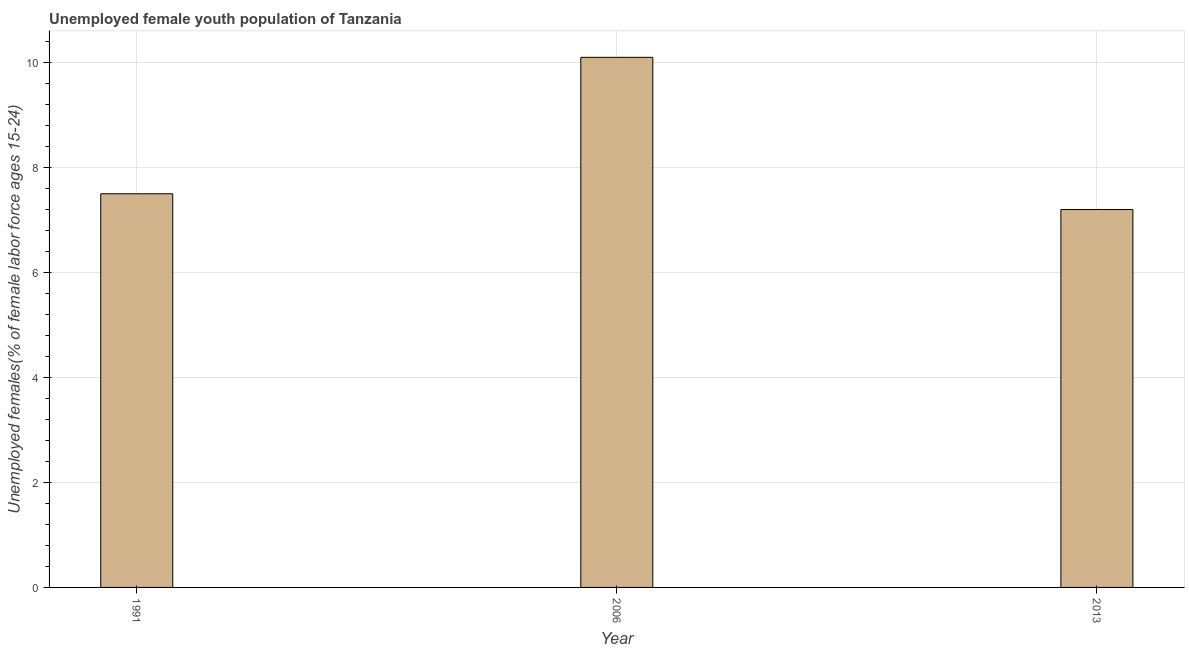Does the graph contain any zero values?
Ensure brevity in your answer.  No. Does the graph contain grids?
Offer a terse response. Yes. What is the title of the graph?
Give a very brief answer. Unemployed female youth population of Tanzania. What is the label or title of the Y-axis?
Your answer should be compact. Unemployed females(% of female labor force ages 15-24). What is the unemployed female youth in 2013?
Your answer should be compact. 7.2. Across all years, what is the maximum unemployed female youth?
Your response must be concise. 10.1. Across all years, what is the minimum unemployed female youth?
Ensure brevity in your answer.  7.2. What is the sum of the unemployed female youth?
Offer a terse response. 24.8. What is the average unemployed female youth per year?
Offer a terse response. 8.27. What is the median unemployed female youth?
Make the answer very short. 7.5. What is the ratio of the unemployed female youth in 1991 to that in 2013?
Your answer should be very brief. 1.04. Is the unemployed female youth in 2006 less than that in 2013?
Make the answer very short. No. Is the difference between the unemployed female youth in 1991 and 2013 greater than the difference between any two years?
Offer a terse response. No. Is the sum of the unemployed female youth in 2006 and 2013 greater than the maximum unemployed female youth across all years?
Offer a terse response. Yes. In how many years, is the unemployed female youth greater than the average unemployed female youth taken over all years?
Your answer should be compact. 1. Are all the bars in the graph horizontal?
Ensure brevity in your answer.  No. What is the difference between two consecutive major ticks on the Y-axis?
Give a very brief answer. 2. What is the Unemployed females(% of female labor force ages 15-24) of 2006?
Make the answer very short. 10.1. What is the Unemployed females(% of female labor force ages 15-24) in 2013?
Offer a very short reply. 7.2. What is the difference between the Unemployed females(% of female labor force ages 15-24) in 1991 and 2006?
Your response must be concise. -2.6. What is the ratio of the Unemployed females(% of female labor force ages 15-24) in 1991 to that in 2006?
Give a very brief answer. 0.74. What is the ratio of the Unemployed females(% of female labor force ages 15-24) in 1991 to that in 2013?
Your response must be concise. 1.04. What is the ratio of the Unemployed females(% of female labor force ages 15-24) in 2006 to that in 2013?
Your answer should be compact. 1.4. 